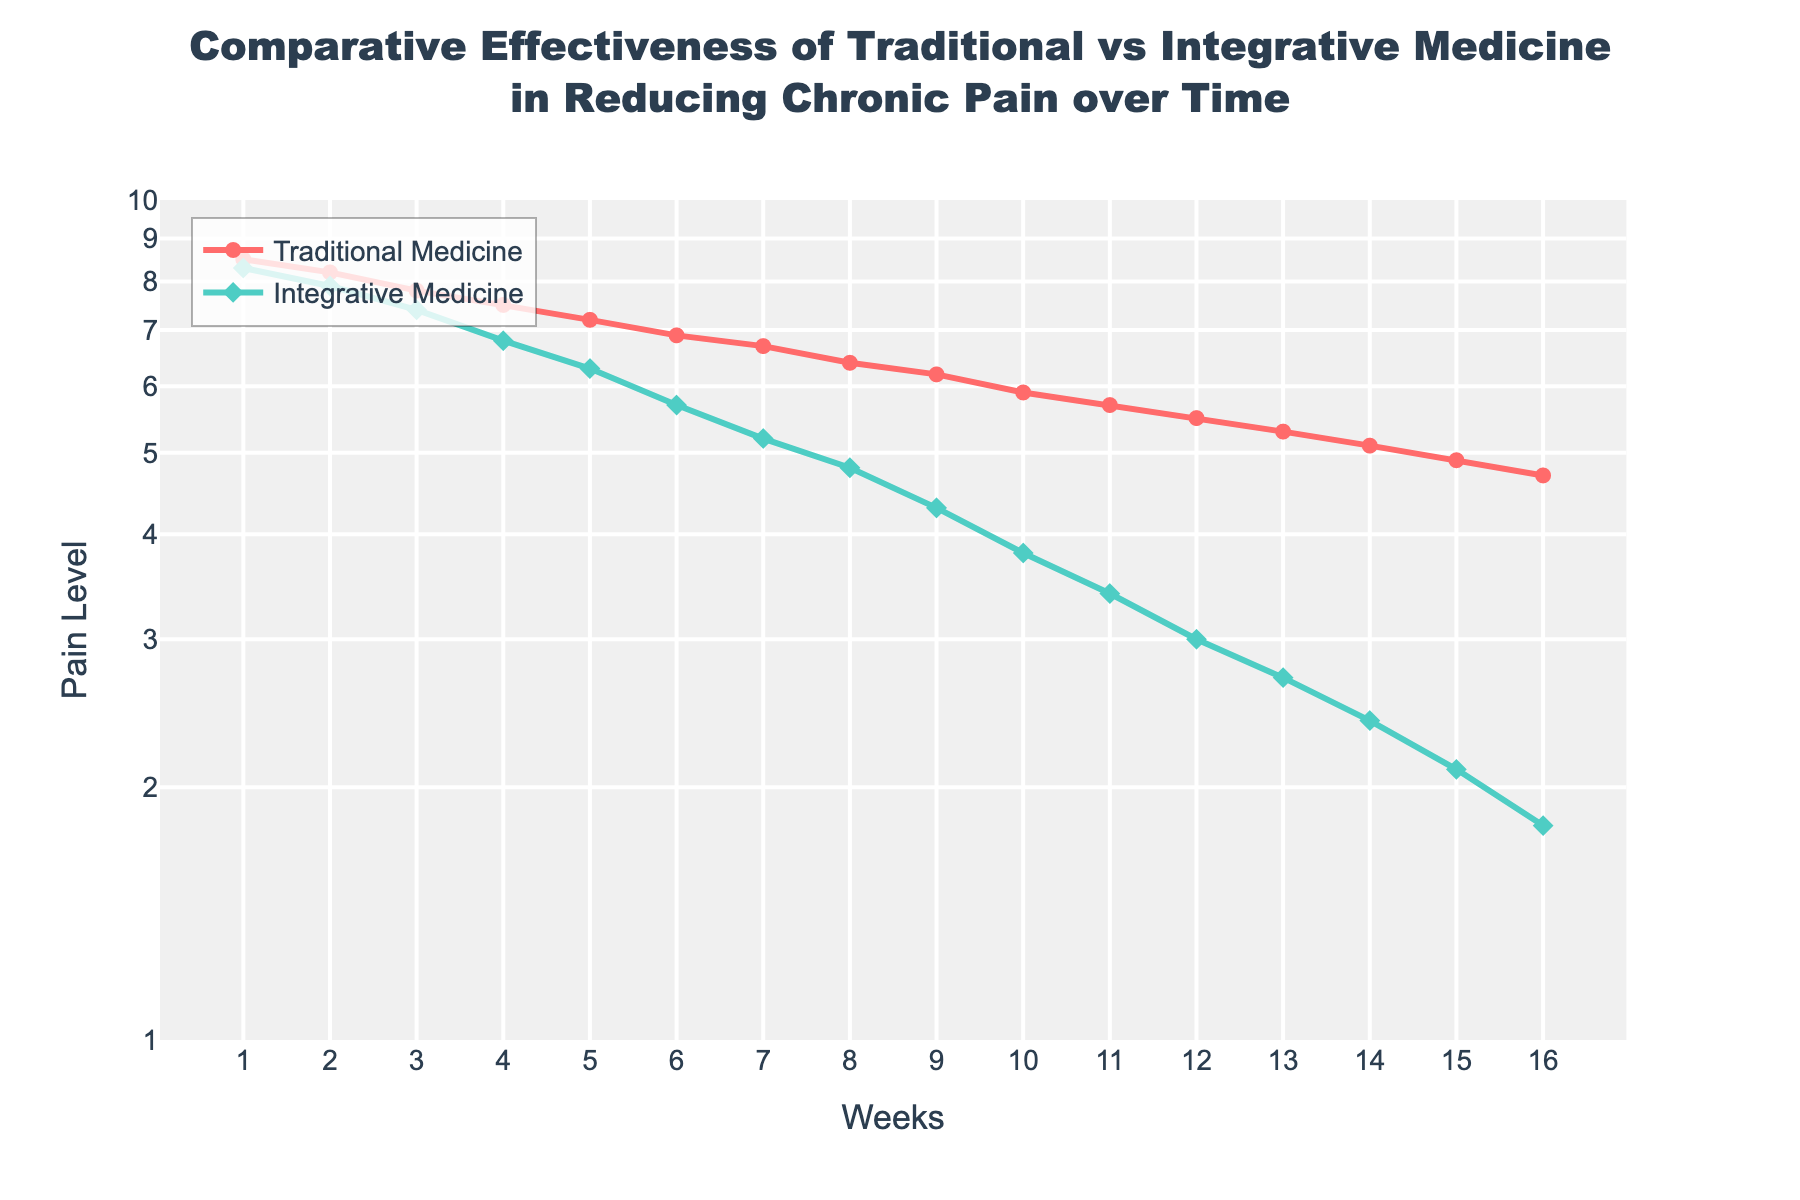What's the overall trend in pain levels for Integrative Medicine over the 16 weeks? The pain levels for Integrative Medicine consistently decrease over the 16-week period. This can be observed by the downward trajectory of the line representing Integrative Medicine on the plot.
Answer: Decreasing Between which weeks does Integrative Medicine show the largest drop in pain levels? By examining the steepness of the line, the largest drop for Integrative Medicine occurs between weeks 1 and 2. The pain level decreases from 8.3 to 7.9, a difference of 0.4, larger than any other interval.
Answer: Weeks 1 and 2 At the end of 16 weeks, which rehabilitation method achieves a lower pain level? At week 16, the pain level for Integrative Medicine is 1.8 and for Traditional Medicine is 4.7. Comparing the two values, Integrative Medicine achieves a lower pain level.
Answer: Integrative Medicine How does the slope of the lines for each rehabilitation method compare in the first 4 weeks? In the first 4 weeks, Integrative Medicine shows a steeper decrease in pain levels going from 8.3 to 6.8, whereas Traditional Medicine goes from 8.5 to 7.5. This indicates Integrative Medicine is more effective in reducing pain quickly initially.
Answer: Integrative Medicine has a steeper slope What is the difference in pain levels between Traditional and Integrative Medicine at week 8? At week 8, the pain levels are 6.4 for Traditional Medicine and 4.8 for Integrative Medicine. The difference is obtained by subtracting these values: 6.4 - 4.8.
Answer: 1.6 Which method shows a constant decrease in pain over time based on visual inspection? The line representing Integrative Medicine has no visible inflection points and decreases smoothly, indicating a constant decrease.
Answer: Integrative Medicine Is the difference in pain levels between the two methods increasing, decreasing, or staying the same over time? Initially, the difference is 0.2, and by week 16, it's 2.9. This indicates the difference is increasing over time as Integrative Medicine becomes more effective at reducing pain compared to Traditional Medicine.
Answer: Increasing What is the pain level range covered by Traditional Medicine from week 1 to week 16? Traditional Medicine pain levels decrease from 8.5 at week 1 to 4.7 at week 16. The range can be calculated by subtracting the lowest value from the highest value: 8.5 - 4.7.
Answer: 3.8 By how much does the pain level for Traditional Medicine decrease from week 1 to week 10? At week 1, the pain level for Traditional Medicine is 8.5, and at week 10, it is 5.9. The decrease is obtained by subtracting these values: 8.5 - 5.9.
Answer: 2.6 